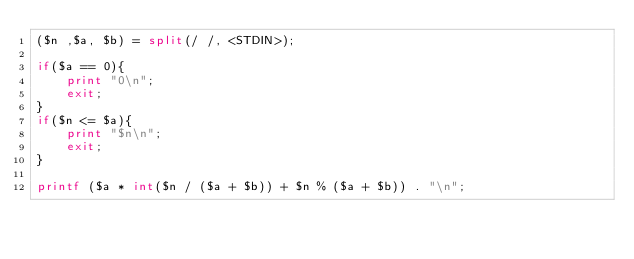<code> <loc_0><loc_0><loc_500><loc_500><_Perl_>($n ,$a, $b) = split(/ /, <STDIN>);

if($a == 0){
	print "0\n";
	exit;
}
if($n <= $a){
	print "$n\n";
	exit;
}

printf ($a * int($n / ($a + $b)) + $n % ($a + $b)) . "\n";
</code> 